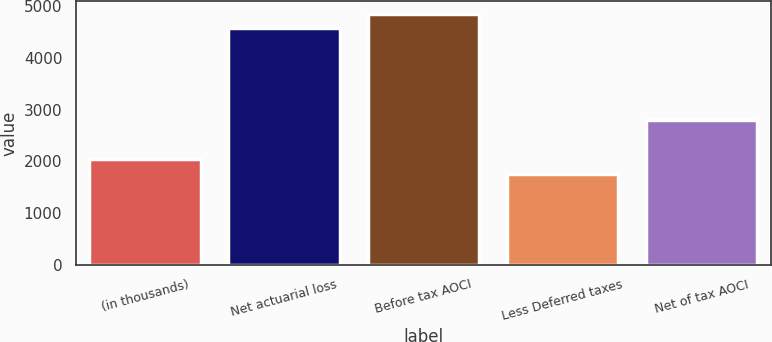<chart> <loc_0><loc_0><loc_500><loc_500><bar_chart><fcel>(in thousands)<fcel>Net actuarial loss<fcel>Before tax AOCI<fcel>Less Deferred taxes<fcel>Net of tax AOCI<nl><fcel>2044.5<fcel>4569<fcel>4849.5<fcel>1764<fcel>2805<nl></chart> 